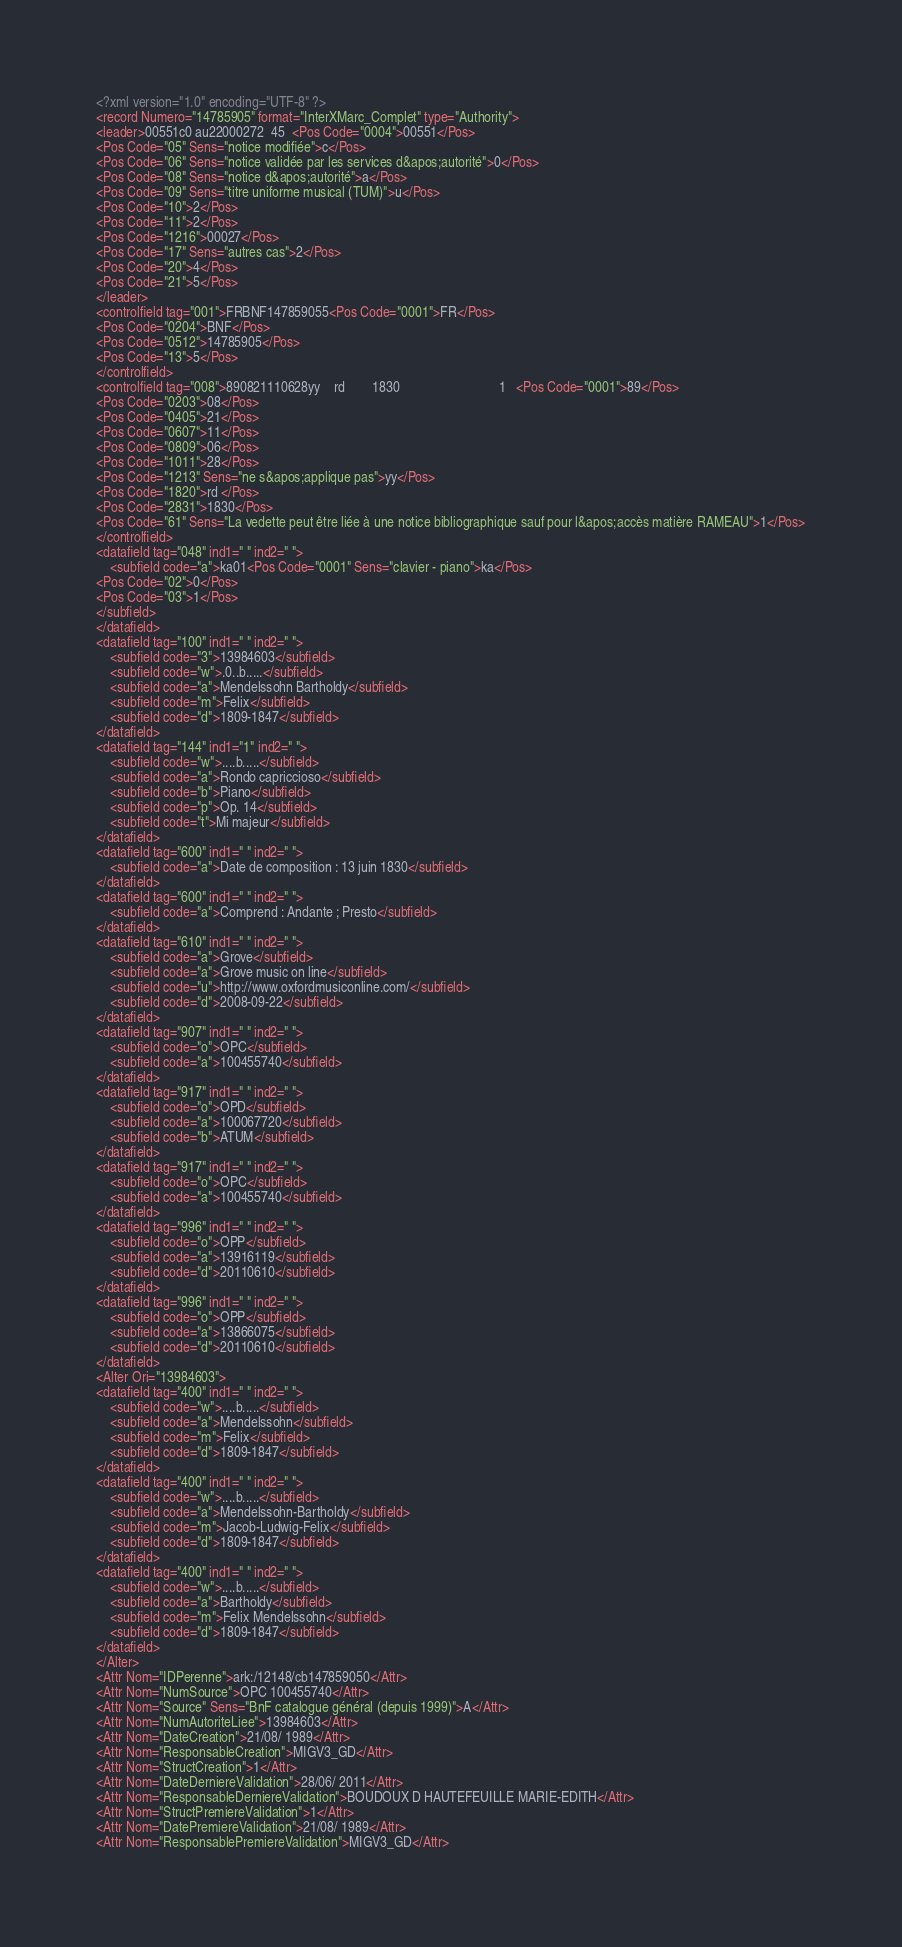<code> <loc_0><loc_0><loc_500><loc_500><_XML_><?xml version="1.0" encoding="UTF-8" ?>
<record Numero="14785905" format="InterXMarc_Complet" type="Authority">
<leader>00551c0 au22000272  45  <Pos Code="0004">00551</Pos>
<Pos Code="05" Sens="notice modifiée">c</Pos>
<Pos Code="06" Sens="notice validée par les services d&apos;autorité">0</Pos>
<Pos Code="08" Sens="notice d&apos;autorité">a</Pos>
<Pos Code="09" Sens="titre uniforme musical (TUM)">u</Pos>
<Pos Code="10">2</Pos>
<Pos Code="11">2</Pos>
<Pos Code="1216">00027</Pos>
<Pos Code="17" Sens="autres cas">2</Pos>
<Pos Code="20">4</Pos>
<Pos Code="21">5</Pos>
</leader>
<controlfield tag="001">FRBNF147859055<Pos Code="0001">FR</Pos>
<Pos Code="0204">BNF</Pos>
<Pos Code="0512">14785905</Pos>
<Pos Code="13">5</Pos>
</controlfield>
<controlfield tag="008">890821110628yy    rd        1830                             1   <Pos Code="0001">89</Pos>
<Pos Code="0203">08</Pos>
<Pos Code="0405">21</Pos>
<Pos Code="0607">11</Pos>
<Pos Code="0809">06</Pos>
<Pos Code="1011">28</Pos>
<Pos Code="1213" Sens="ne s&apos;applique pas">yy</Pos>
<Pos Code="1820">rd </Pos>
<Pos Code="2831">1830</Pos>
<Pos Code="61" Sens="La vedette peut être liée à une notice bibliographique sauf pour l&apos;accès matière RAMEAU">1</Pos>
</controlfield>
<datafield tag="048" ind1=" " ind2=" ">
	<subfield code="a">ka01<Pos Code="0001" Sens="clavier - piano">ka</Pos>
<Pos Code="02">0</Pos>
<Pos Code="03">1</Pos>
</subfield>
</datafield>
<datafield tag="100" ind1=" " ind2=" ">
	<subfield code="3">13984603</subfield>
	<subfield code="w">.0..b.....</subfield>
	<subfield code="a">Mendelssohn Bartholdy</subfield>
	<subfield code="m">Felix</subfield>
	<subfield code="d">1809-1847</subfield>
</datafield>
<datafield tag="144" ind1="1" ind2=" ">
	<subfield code="w">....b.....</subfield>
	<subfield code="a">Rondo capriccioso</subfield>
	<subfield code="b">Piano</subfield>
	<subfield code="p">Op. 14</subfield>
	<subfield code="t">Mi majeur</subfield>
</datafield>
<datafield tag="600" ind1=" " ind2=" ">
	<subfield code="a">Date de composition : 13 juin 1830</subfield>
</datafield>
<datafield tag="600" ind1=" " ind2=" ">
	<subfield code="a">Comprend : Andante ; Presto</subfield>
</datafield>
<datafield tag="610" ind1=" " ind2=" ">
	<subfield code="a">Grove</subfield>
	<subfield code="a">Grove music on line</subfield>
	<subfield code="u">http://www.oxfordmusiconline.com/</subfield>
	<subfield code="d">2008-09-22</subfield>
</datafield>
<datafield tag="907" ind1=" " ind2=" ">
	<subfield code="o">OPC</subfield>
	<subfield code="a">100455740</subfield>
</datafield>
<datafield tag="917" ind1=" " ind2=" ">
	<subfield code="o">OPD</subfield>
	<subfield code="a">100067720</subfield>
	<subfield code="b">ATUM</subfield>
</datafield>
<datafield tag="917" ind1=" " ind2=" ">
	<subfield code="o">OPC</subfield>
	<subfield code="a">100455740</subfield>
</datafield>
<datafield tag="996" ind1=" " ind2=" ">
	<subfield code="o">OPP</subfield>
	<subfield code="a">13916119</subfield>
	<subfield code="d">20110610</subfield>
</datafield>
<datafield tag="996" ind1=" " ind2=" ">
	<subfield code="o">OPP</subfield>
	<subfield code="a">13866075</subfield>
	<subfield code="d">20110610</subfield>
</datafield>
<Alter Ori="13984603">
<datafield tag="400" ind1=" " ind2=" ">
	<subfield code="w">....b.....</subfield>
	<subfield code="a">Mendelssohn</subfield>
	<subfield code="m">Felix</subfield>
	<subfield code="d">1809-1847</subfield>
</datafield>
<datafield tag="400" ind1=" " ind2=" ">
	<subfield code="w">....b.....</subfield>
	<subfield code="a">Mendelssohn-Bartholdy</subfield>
	<subfield code="m">Jacob-Ludwig-Felix</subfield>
	<subfield code="d">1809-1847</subfield>
</datafield>
<datafield tag="400" ind1=" " ind2=" ">
	<subfield code="w">....b.....</subfield>
	<subfield code="a">Bartholdy</subfield>
	<subfield code="m">Felix Mendelssohn</subfield>
	<subfield code="d">1809-1847</subfield>
</datafield>
</Alter>
<Attr Nom="IDPerenne">ark:/12148/cb147859050</Attr>
<Attr Nom="NumSource">OPC 100455740</Attr>
<Attr Nom="Source" Sens="BnF catalogue général (depuis 1999)">A</Attr>
<Attr Nom="NumAutoriteLiee">13984603</Attr>
<Attr Nom="DateCreation">21/08/ 1989</Attr>
<Attr Nom="ResponsableCreation">MIGV3_GD</Attr>
<Attr Nom="StructCreation">1</Attr>
<Attr Nom="DateDerniereValidation">28/06/ 2011</Attr>
<Attr Nom="ResponsableDerniereValidation">BOUDOUX D HAUTEFEUILLE MARIE-EDITH</Attr>
<Attr Nom="StructPremiereValidation">1</Attr>
<Attr Nom="DatePremiereValidation">21/08/ 1989</Attr>
<Attr Nom="ResponsablePremiereValidation">MIGV3_GD</Attr></code> 